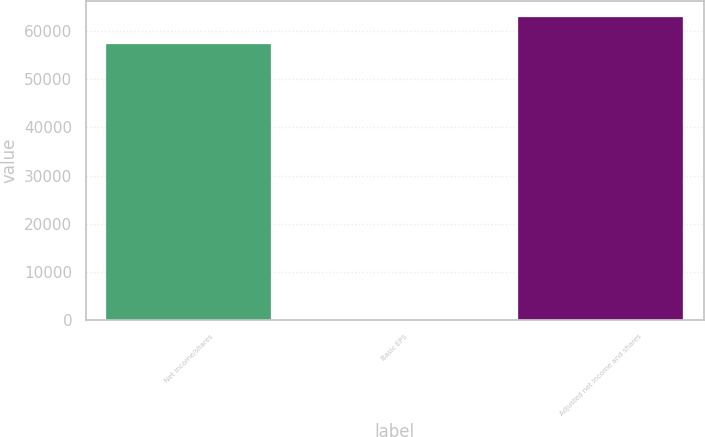<chart> <loc_0><loc_0><loc_500><loc_500><bar_chart><fcel>Net income/shares<fcel>Basic EPS<fcel>Adjusted net income and shares<nl><fcel>57196<fcel>0.31<fcel>62972.3<nl></chart> 